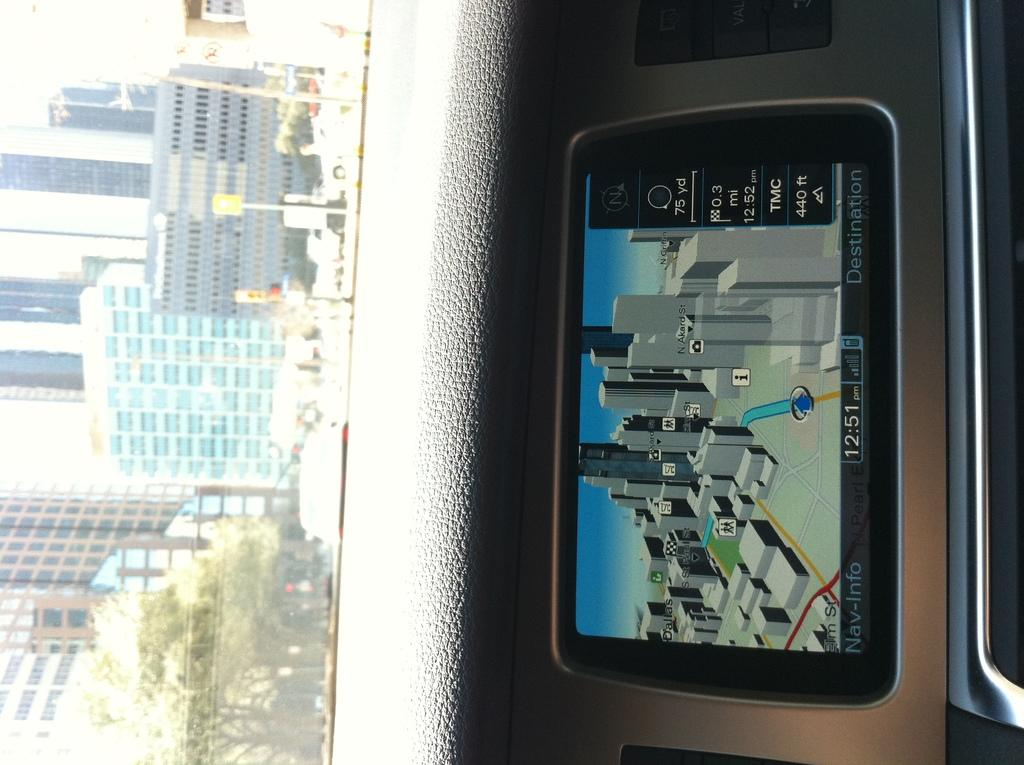<image>
Describe the image concisely. Screen on a dashboard which shows the current time at 12:51. 